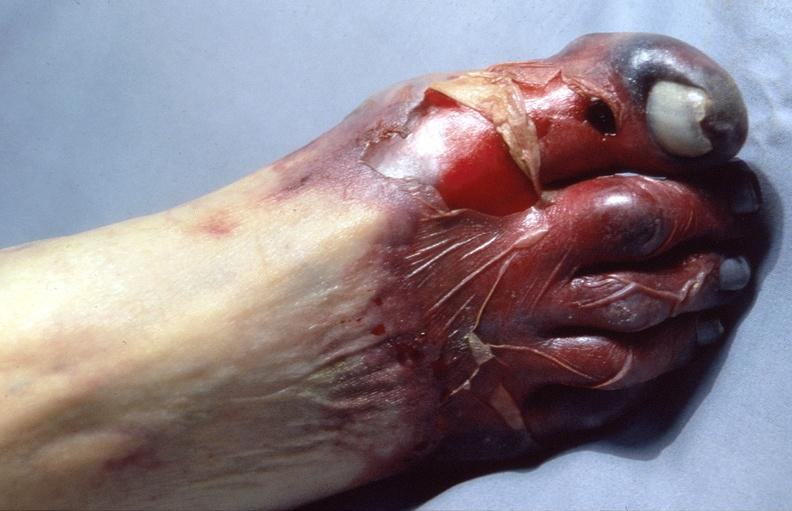does this image show skin ulceration and necrosis, disseminated intravascular coagulation due to acetaminophen toxicity?
Answer the question using a single word or phrase. Yes 